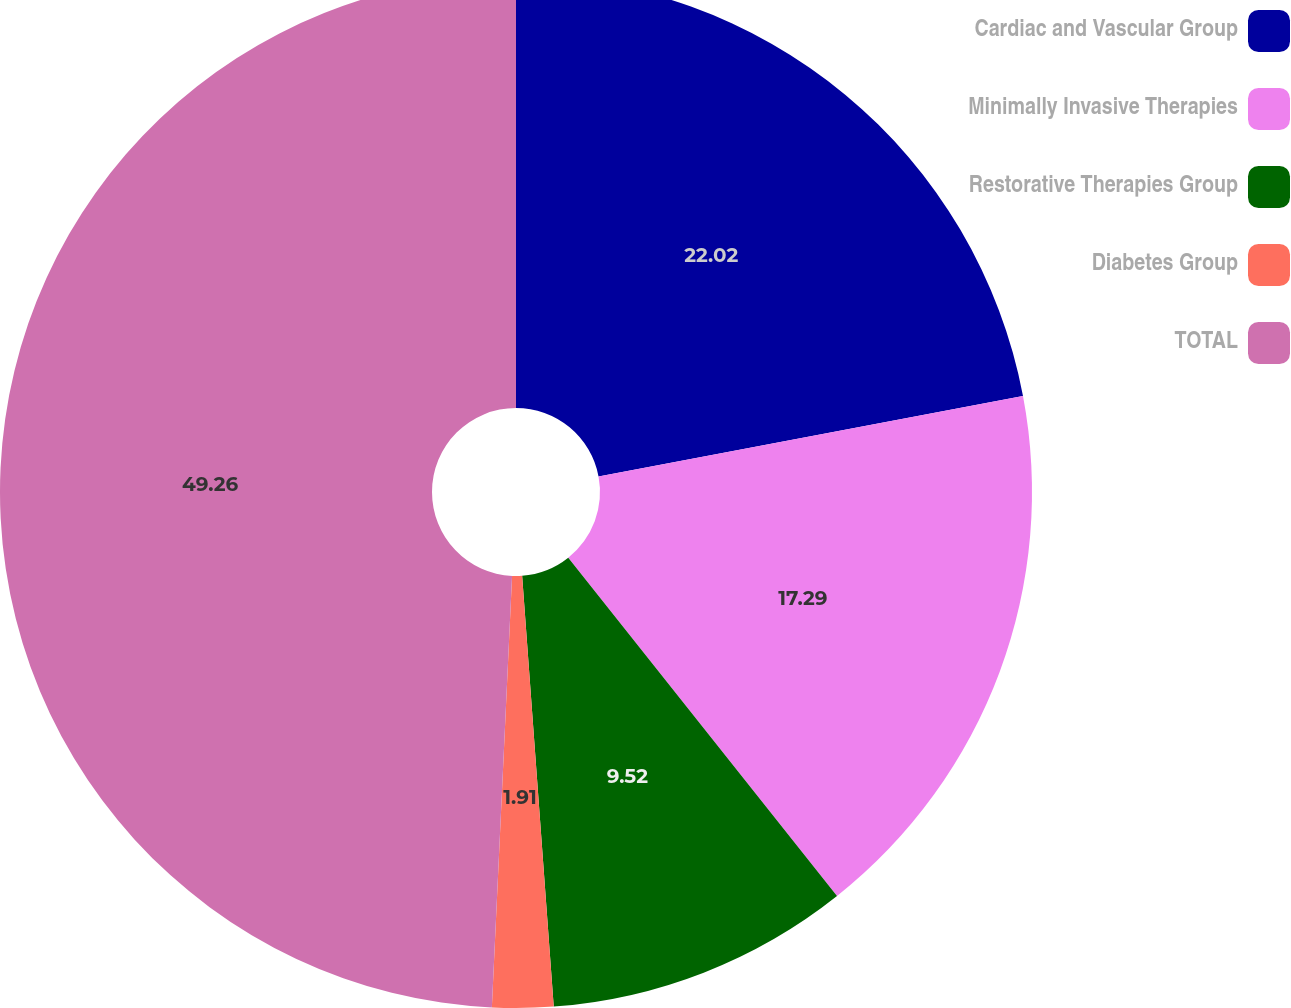Convert chart. <chart><loc_0><loc_0><loc_500><loc_500><pie_chart><fcel>Cardiac and Vascular Group<fcel>Minimally Invasive Therapies<fcel>Restorative Therapies Group<fcel>Diabetes Group<fcel>TOTAL<nl><fcel>22.02%<fcel>17.29%<fcel>9.52%<fcel>1.91%<fcel>49.25%<nl></chart> 